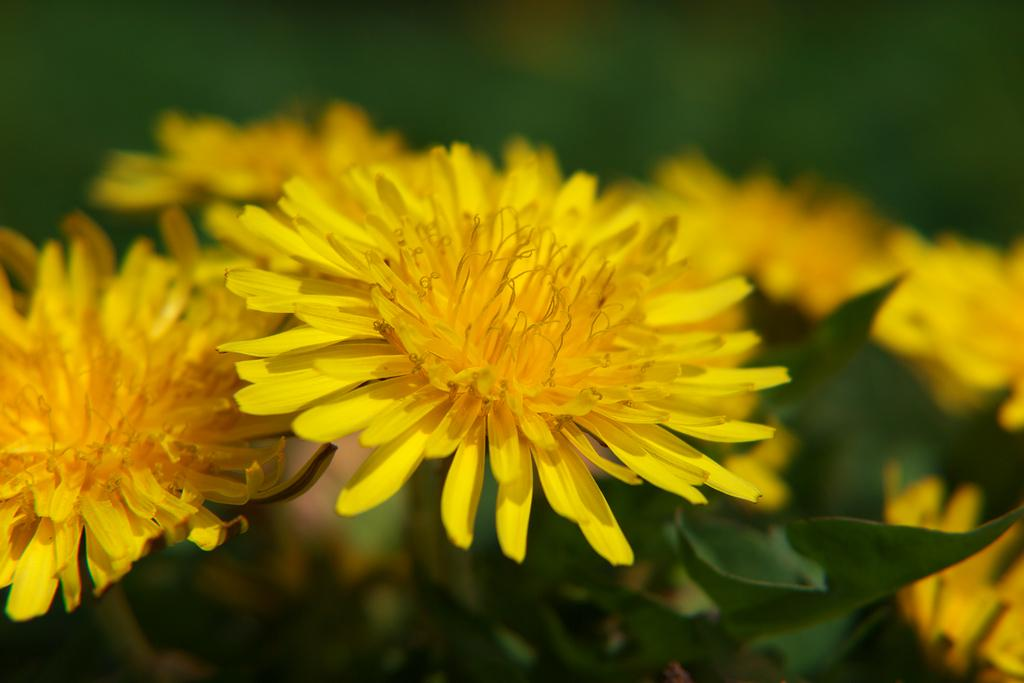What is the main subject of the image? The main subject of the image is yellow flowers. Can you describe the flowers in the image? The yellow flowers are in the center of the image. What can be observed about the background of the image? The background area of the image is blurred. What type of summer activity is taking place in the image? There is no summer activity present in the image; it features yellow flowers in the center with a blurred background. 